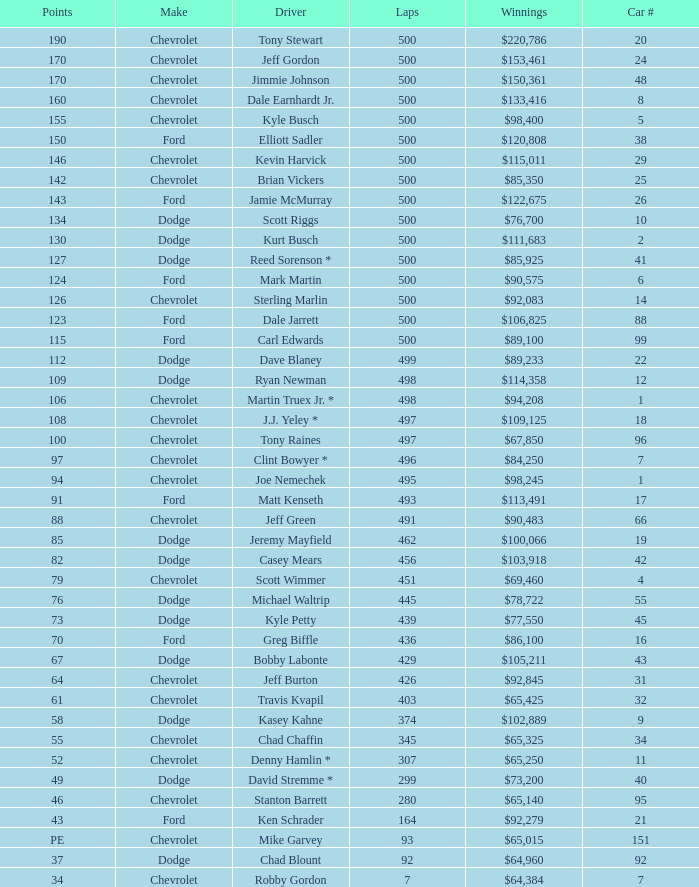What is the average car number of all the drivers who have won $111,683? 2.0. Write the full table. {'header': ['Points', 'Make', 'Driver', 'Laps', 'Winnings', 'Car #'], 'rows': [['190', 'Chevrolet', 'Tony Stewart', '500', '$220,786', '20'], ['170', 'Chevrolet', 'Jeff Gordon', '500', '$153,461', '24'], ['170', 'Chevrolet', 'Jimmie Johnson', '500', '$150,361', '48'], ['160', 'Chevrolet', 'Dale Earnhardt Jr.', '500', '$133,416', '8'], ['155', 'Chevrolet', 'Kyle Busch', '500', '$98,400', '5'], ['150', 'Ford', 'Elliott Sadler', '500', '$120,808', '38'], ['146', 'Chevrolet', 'Kevin Harvick', '500', '$115,011', '29'], ['142', 'Chevrolet', 'Brian Vickers', '500', '$85,350', '25'], ['143', 'Ford', 'Jamie McMurray', '500', '$122,675', '26'], ['134', 'Dodge', 'Scott Riggs', '500', '$76,700', '10'], ['130', 'Dodge', 'Kurt Busch', '500', '$111,683', '2'], ['127', 'Dodge', 'Reed Sorenson *', '500', '$85,925', '41'], ['124', 'Ford', 'Mark Martin', '500', '$90,575', '6'], ['126', 'Chevrolet', 'Sterling Marlin', '500', '$92,083', '14'], ['123', 'Ford', 'Dale Jarrett', '500', '$106,825', '88'], ['115', 'Ford', 'Carl Edwards', '500', '$89,100', '99'], ['112', 'Dodge', 'Dave Blaney', '499', '$89,233', '22'], ['109', 'Dodge', 'Ryan Newman', '498', '$114,358', '12'], ['106', 'Chevrolet', 'Martin Truex Jr. *', '498', '$94,208', '1'], ['108', 'Chevrolet', 'J.J. Yeley *', '497', '$109,125', '18'], ['100', 'Chevrolet', 'Tony Raines', '497', '$67,850', '96'], ['97', 'Chevrolet', 'Clint Bowyer *', '496', '$84,250', '7'], ['94', 'Chevrolet', 'Joe Nemechek', '495', '$98,245', '1'], ['91', 'Ford', 'Matt Kenseth', '493', '$113,491', '17'], ['88', 'Chevrolet', 'Jeff Green', '491', '$90,483', '66'], ['85', 'Dodge', 'Jeremy Mayfield', '462', '$100,066', '19'], ['82', 'Dodge', 'Casey Mears', '456', '$103,918', '42'], ['79', 'Chevrolet', 'Scott Wimmer', '451', '$69,460', '4'], ['76', 'Dodge', 'Michael Waltrip', '445', '$78,722', '55'], ['73', 'Dodge', 'Kyle Petty', '439', '$77,550', '45'], ['70', 'Ford', 'Greg Biffle', '436', '$86,100', '16'], ['67', 'Dodge', 'Bobby Labonte', '429', '$105,211', '43'], ['64', 'Chevrolet', 'Jeff Burton', '426', '$92,845', '31'], ['61', 'Chevrolet', 'Travis Kvapil', '403', '$65,425', '32'], ['58', 'Dodge', 'Kasey Kahne', '374', '$102,889', '9'], ['55', 'Chevrolet', 'Chad Chaffin', '345', '$65,325', '34'], ['52', 'Chevrolet', 'Denny Hamlin *', '307', '$65,250', '11'], ['49', 'Dodge', 'David Stremme *', '299', '$73,200', '40'], ['46', 'Chevrolet', 'Stanton Barrett', '280', '$65,140', '95'], ['43', 'Ford', 'Ken Schrader', '164', '$92,279', '21'], ['PE', 'Chevrolet', 'Mike Garvey', '93', '$65,015', '151'], ['37', 'Dodge', 'Chad Blount', '92', '$64,960', '92'], ['34', 'Chevrolet', 'Robby Gordon', '7', '$64,384', '7']]} 